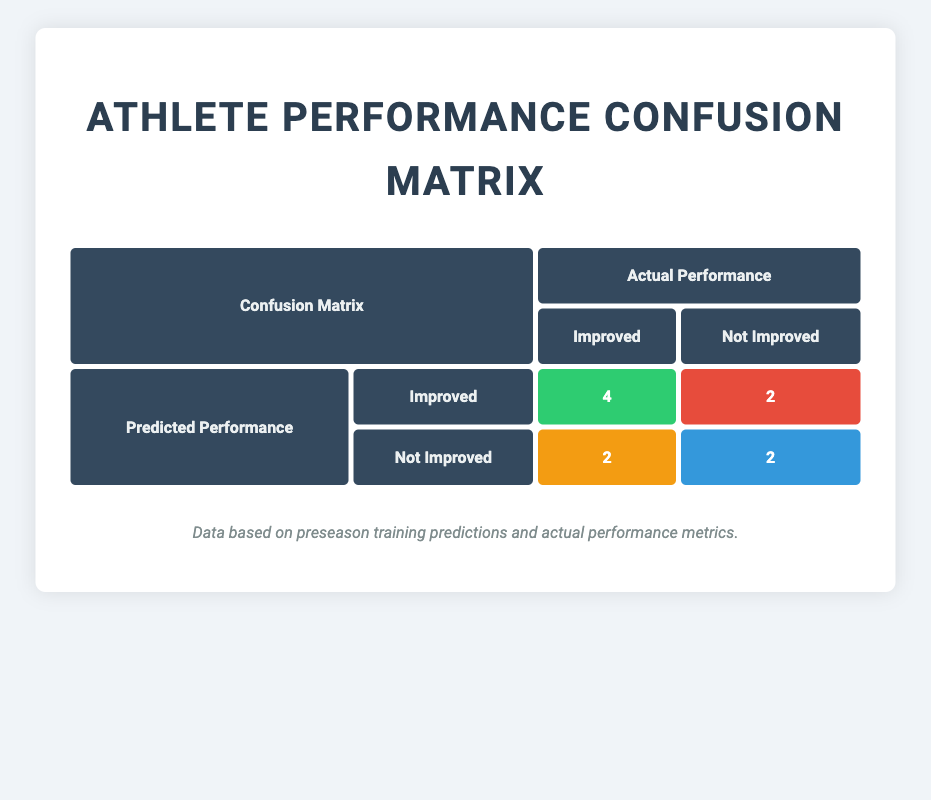What is the number of true positives in the confusion matrix? The true positives are found in the cell where both predicted and actual performance are "Improved." According to the table, that cell contains the value 4.
Answer: 4 How many athletes were predicted to improve but did not? This can be found in the second row of the confusion matrix under "Predicted Performance" as "Improved" and "Not Improved," which shows a value of 2.
Answer: 2 What is the total number of athletes who actually improved? To find this, we need to sum the true positives (4) and false negatives (2) in the actual performance row for "Improved." Thus, 4 + 2 = 6.
Answer: 6 Were there any athletes whose predicted performance did not improve and actually improved? This can be checked in the confusion matrix under "Not Improved" for predicted performance, and "Improved" for actual performance, which shows a value of 2 indicating that there are athletes who fall into this category.
Answer: Yes What is the difference between the number of true negatives and false negatives? The true negatives are located in the cell where both predicted and actual performance are "Not Improved" and have a value of 2. The false negatives are in the "Improved" row under "Not Improved," which has a value of 2 as well. Therefore, the difference is 2 - 2 = 0.
Answer: 0 How many athletes were classified as false positives? This is found in the confusion matrix under "Predicted Performance" as "Improved" and "Not Improved," which shows a value of 2.
Answer: 2 What percentage of the athletes were accurately predicted to improve? The accurate predictions of improvement are the true positives (4) out of the total athletes (10), so the percentage is (4/10)*100 = 40%.
Answer: 40% What proportion of the athletes had predicted performance as "Not Improved"? To determine this, we can look at the predicted performance row for "Not Improved," which has 4 athletes (2 true negatives and 2 false negatives). Thus, the proportion is 4/10 = 0.4.
Answer: 0.4 